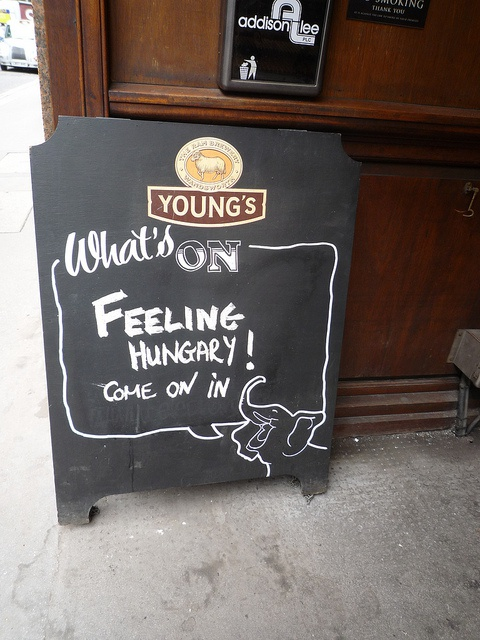Describe the objects in this image and their specific colors. I can see chair in white, black, and gray tones and car in lightgray, white, and darkgray tones in this image. 